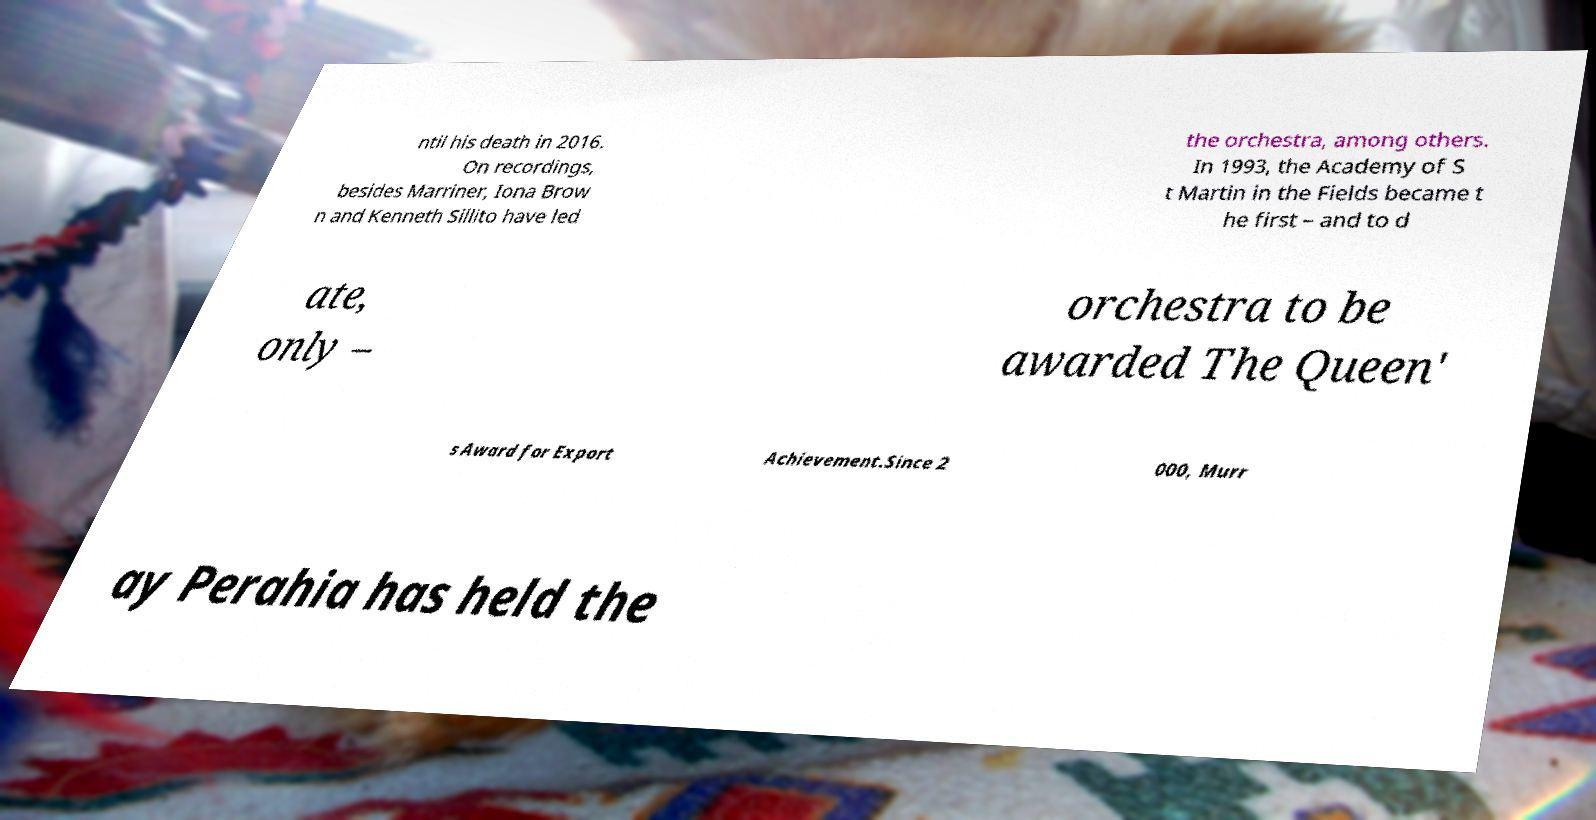Could you extract and type out the text from this image? ntil his death in 2016. On recordings, besides Marriner, Iona Brow n and Kenneth Sillito have led the orchestra, among others. In 1993, the Academy of S t Martin in the Fields became t he first – and to d ate, only – orchestra to be awarded The Queen' s Award for Export Achievement.Since 2 000, Murr ay Perahia has held the 